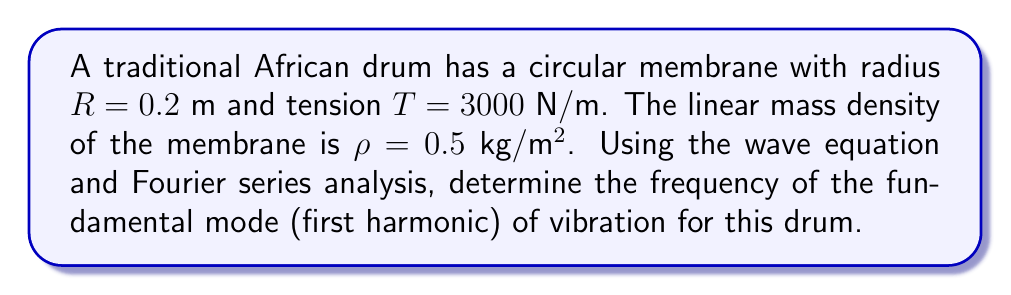Provide a solution to this math problem. To solve this problem, we'll use the wave equation for a circular membrane and follow these steps:

1) The wave equation for a circular membrane is:

   $$\frac{\partial^2 u}{\partial t^2} = c^2 \nabla^2 u$$

   where $c$ is the wave speed.

2) For a circular membrane, the wave speed is given by:

   $$c = \sqrt{\frac{T}{\rho}}$$

3) Substituting the given values:

   $$c = \sqrt{\frac{3000 \text{ N/m}}{0.5 \text{ kg/m²}}} = \sqrt{6000} \approx 77.46 \text{ m/s}$$

4) The general solution for the vibration modes of a circular membrane is:

   $$f_{mn} = \frac{\alpha_{mn}}{2\pi R} \sqrt{\frac{T}{\rho}}$$

   where $\alpha_{mn}$ are the zeros of the Bessel function of the first kind.

5) For the fundamental mode (first harmonic), $m = 0$ and $n = 1$, and $\alpha_{01} \approx 2.4048$.

6) Substituting all values into the equation:

   $$f_{01} = \frac{2.4048}{2\pi(0.2 \text{ m})} \sqrt{\frac{3000 \text{ N/m}}{0.5 \text{ kg/m²}}}$$

7) Simplifying:

   $$f_{01} = \frac{2.4048}{0.4\pi} \cdot 77.46 \approx 147.04 \text{ Hz}$$
Answer: $147.04 \text{ Hz}$ 